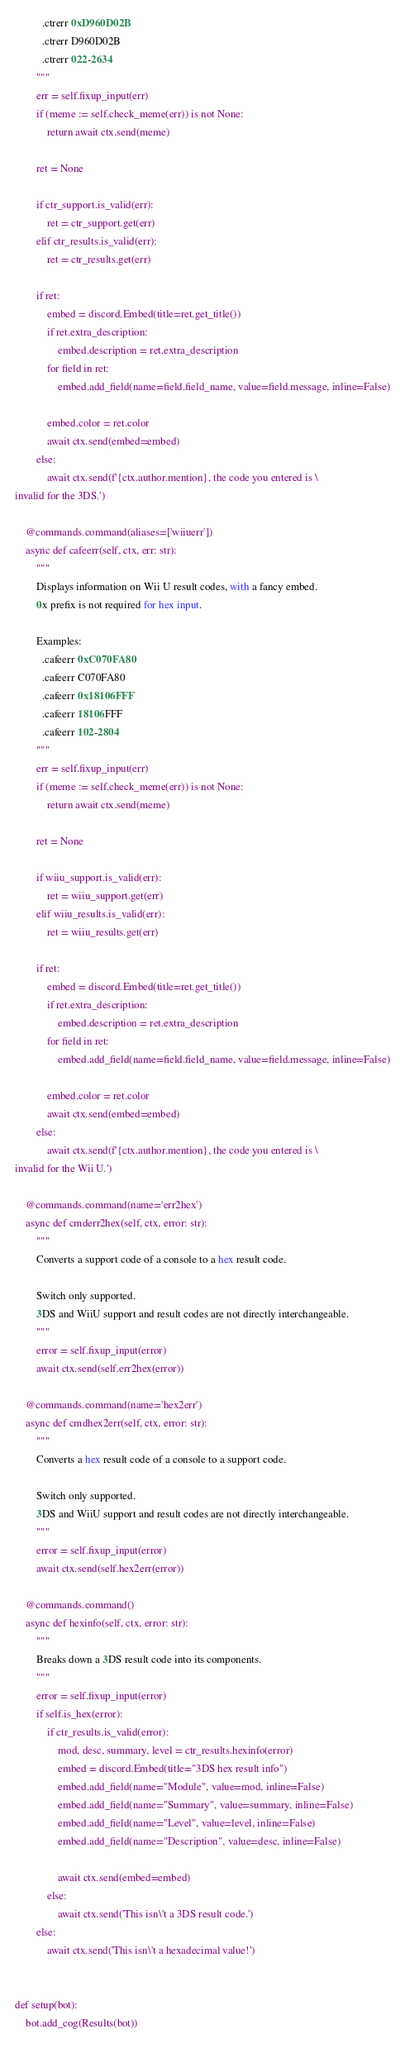<code> <loc_0><loc_0><loc_500><loc_500><_Python_>          .ctrerr 0xD960D02B
          .ctrerr D960D02B
          .ctrerr 022-2634
        """
        err = self.fixup_input(err)
        if (meme := self.check_meme(err)) is not None:
            return await ctx.send(meme)

        ret = None

        if ctr_support.is_valid(err):
            ret = ctr_support.get(err)
        elif ctr_results.is_valid(err):
            ret = ctr_results.get(err)

        if ret:
            embed = discord.Embed(title=ret.get_title())
            if ret.extra_description:
                embed.description = ret.extra_description
            for field in ret:
                embed.add_field(name=field.field_name, value=field.message, inline=False)

            embed.color = ret.color
            await ctx.send(embed=embed)
        else:
            await ctx.send(f'{ctx.author.mention}, the code you entered is \
invalid for the 3DS.')

    @commands.command(aliases=['wiiuerr'])
    async def cafeerr(self, ctx, err: str):
        """
        Displays information on Wii U result codes, with a fancy embed.
        0x prefix is not required for hex input.

        Examples:
          .cafeerr 0xC070FA80
          .cafeerr C070FA80
          .cafeerr 0x18106FFF
          .cafeerr 18106FFF
          .cafeerr 102-2804
        """
        err = self.fixup_input(err)
        if (meme := self.check_meme(err)) is not None:
            return await ctx.send(meme)

        ret = None

        if wiiu_support.is_valid(err):
            ret = wiiu_support.get(err)
        elif wiiu_results.is_valid(err):
            ret = wiiu_results.get(err)

        if ret:
            embed = discord.Embed(title=ret.get_title())
            if ret.extra_description:
                embed.description = ret.extra_description
            for field in ret:
                embed.add_field(name=field.field_name, value=field.message, inline=False)

            embed.color = ret.color
            await ctx.send(embed=embed)
        else:
            await ctx.send(f'{ctx.author.mention}, the code you entered is \
invalid for the Wii U.')

    @commands.command(name='err2hex')
    async def cmderr2hex(self, ctx, error: str):
        """
        Converts a support code of a console to a hex result code.

        Switch only supported.
        3DS and WiiU support and result codes are not directly interchangeable.
        """
        error = self.fixup_input(error)
        await ctx.send(self.err2hex(error))

    @commands.command(name='hex2err')
    async def cmdhex2err(self, ctx, error: str):
        """
        Converts a hex result code of a console to a support code.

        Switch only supported.
        3DS and WiiU support and result codes are not directly interchangeable.
        """
        error = self.fixup_input(error)
        await ctx.send(self.hex2err(error))

    @commands.command()
    async def hexinfo(self, ctx, error: str):
        """
        Breaks down a 3DS result code into its components.
        """
        error = self.fixup_input(error)
        if self.is_hex(error):
            if ctr_results.is_valid(error):
                mod, desc, summary, level = ctr_results.hexinfo(error)
                embed = discord.Embed(title="3DS hex result info")
                embed.add_field(name="Module", value=mod, inline=False)
                embed.add_field(name="Summary", value=summary, inline=False)
                embed.add_field(name="Level", value=level, inline=False)
                embed.add_field(name="Description", value=desc, inline=False)

                await ctx.send(embed=embed)
            else:
                await ctx.send('This isn\'t a 3DS result code.')
        else:
            await ctx.send('This isn\'t a hexadecimal value!')


def setup(bot):
    bot.add_cog(Results(bot))
</code> 